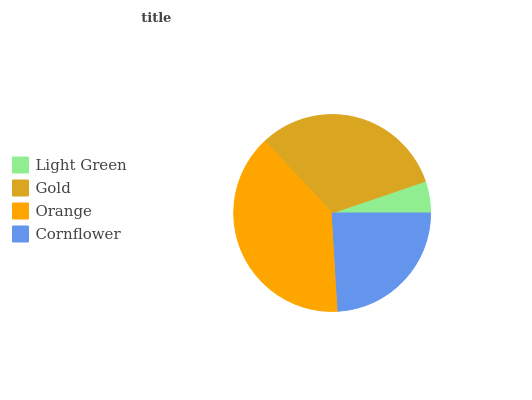Is Light Green the minimum?
Answer yes or no. Yes. Is Orange the maximum?
Answer yes or no. Yes. Is Gold the minimum?
Answer yes or no. No. Is Gold the maximum?
Answer yes or no. No. Is Gold greater than Light Green?
Answer yes or no. Yes. Is Light Green less than Gold?
Answer yes or no. Yes. Is Light Green greater than Gold?
Answer yes or no. No. Is Gold less than Light Green?
Answer yes or no. No. Is Gold the high median?
Answer yes or no. Yes. Is Cornflower the low median?
Answer yes or no. Yes. Is Cornflower the high median?
Answer yes or no. No. Is Gold the low median?
Answer yes or no. No. 